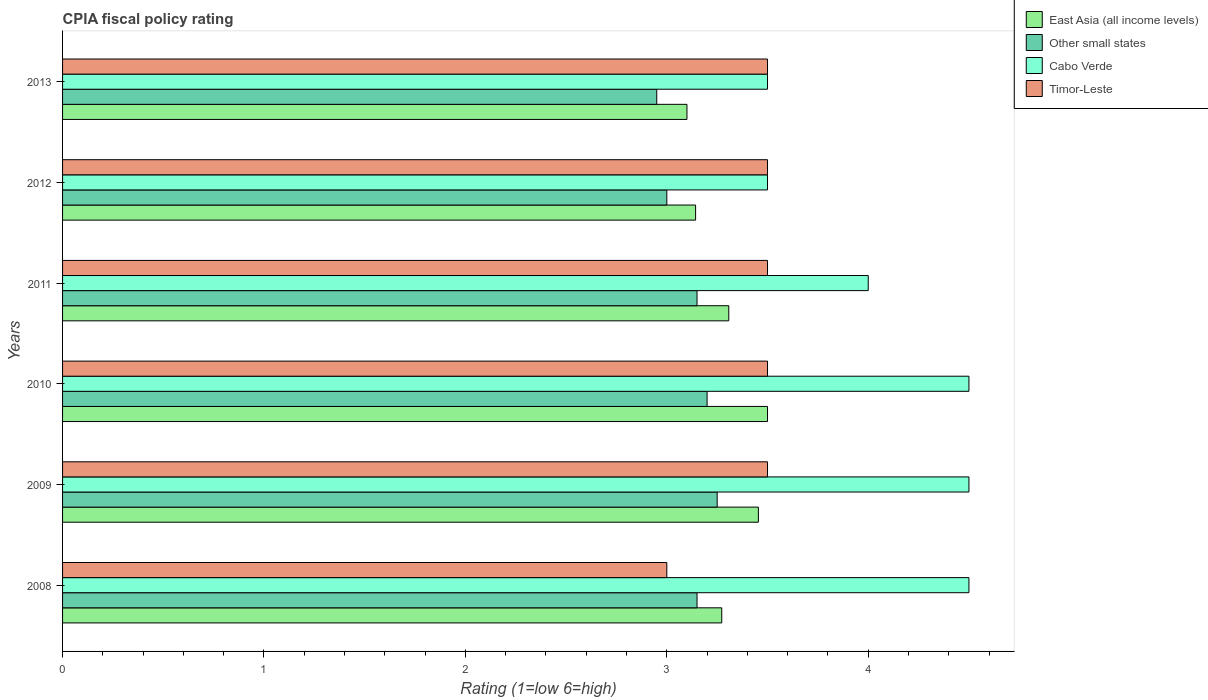How many different coloured bars are there?
Give a very brief answer. 4. Are the number of bars per tick equal to the number of legend labels?
Keep it short and to the point. Yes. How many bars are there on the 3rd tick from the bottom?
Ensure brevity in your answer.  4. What is the CPIA rating in East Asia (all income levels) in 2012?
Provide a succinct answer. 3.14. Across all years, what is the maximum CPIA rating in Other small states?
Offer a terse response. 3.25. Across all years, what is the minimum CPIA rating in Other small states?
Keep it short and to the point. 2.95. In which year was the CPIA rating in Cabo Verde minimum?
Ensure brevity in your answer.  2012. What is the total CPIA rating in Other small states in the graph?
Make the answer very short. 18.7. What is the difference between the CPIA rating in Other small states in 2009 and that in 2010?
Offer a very short reply. 0.05. What is the difference between the CPIA rating in East Asia (all income levels) in 2011 and the CPIA rating in Cabo Verde in 2013?
Make the answer very short. -0.19. What is the average CPIA rating in Other small states per year?
Your answer should be compact. 3.12. In the year 2013, what is the difference between the CPIA rating in Cabo Verde and CPIA rating in East Asia (all income levels)?
Provide a succinct answer. 0.4. Is the CPIA rating in Other small states in 2011 less than that in 2013?
Offer a very short reply. No. What is the difference between the highest and the second highest CPIA rating in East Asia (all income levels)?
Your answer should be compact. 0.05. What is the difference between the highest and the lowest CPIA rating in Other small states?
Offer a terse response. 0.3. In how many years, is the CPIA rating in Cabo Verde greater than the average CPIA rating in Cabo Verde taken over all years?
Provide a succinct answer. 3. What does the 3rd bar from the top in 2009 represents?
Your response must be concise. Other small states. What does the 3rd bar from the bottom in 2013 represents?
Provide a succinct answer. Cabo Verde. How many bars are there?
Provide a succinct answer. 24. Are all the bars in the graph horizontal?
Ensure brevity in your answer.  Yes. How many years are there in the graph?
Offer a very short reply. 6. Are the values on the major ticks of X-axis written in scientific E-notation?
Provide a succinct answer. No. Where does the legend appear in the graph?
Make the answer very short. Top right. How are the legend labels stacked?
Ensure brevity in your answer.  Vertical. What is the title of the graph?
Your answer should be compact. CPIA fiscal policy rating. Does "Peru" appear as one of the legend labels in the graph?
Provide a succinct answer. No. What is the label or title of the Y-axis?
Make the answer very short. Years. What is the Rating (1=low 6=high) in East Asia (all income levels) in 2008?
Offer a terse response. 3.27. What is the Rating (1=low 6=high) of Other small states in 2008?
Provide a short and direct response. 3.15. What is the Rating (1=low 6=high) of Timor-Leste in 2008?
Ensure brevity in your answer.  3. What is the Rating (1=low 6=high) in East Asia (all income levels) in 2009?
Offer a very short reply. 3.45. What is the Rating (1=low 6=high) in Other small states in 2009?
Your response must be concise. 3.25. What is the Rating (1=low 6=high) in Timor-Leste in 2010?
Provide a succinct answer. 3.5. What is the Rating (1=low 6=high) in East Asia (all income levels) in 2011?
Give a very brief answer. 3.31. What is the Rating (1=low 6=high) of Other small states in 2011?
Keep it short and to the point. 3.15. What is the Rating (1=low 6=high) in Cabo Verde in 2011?
Make the answer very short. 4. What is the Rating (1=low 6=high) in East Asia (all income levels) in 2012?
Your response must be concise. 3.14. What is the Rating (1=low 6=high) of Other small states in 2012?
Provide a succinct answer. 3. What is the Rating (1=low 6=high) in Cabo Verde in 2012?
Your answer should be compact. 3.5. What is the Rating (1=low 6=high) in Timor-Leste in 2012?
Provide a short and direct response. 3.5. What is the Rating (1=low 6=high) of Other small states in 2013?
Keep it short and to the point. 2.95. What is the Rating (1=low 6=high) in Cabo Verde in 2013?
Give a very brief answer. 3.5. What is the Rating (1=low 6=high) in Timor-Leste in 2013?
Your response must be concise. 3.5. Across all years, what is the maximum Rating (1=low 6=high) of East Asia (all income levels)?
Offer a very short reply. 3.5. Across all years, what is the minimum Rating (1=low 6=high) in Other small states?
Give a very brief answer. 2.95. Across all years, what is the minimum Rating (1=low 6=high) in Timor-Leste?
Your answer should be very brief. 3. What is the total Rating (1=low 6=high) of East Asia (all income levels) in the graph?
Your response must be concise. 19.78. What is the total Rating (1=low 6=high) in Timor-Leste in the graph?
Offer a terse response. 20.5. What is the difference between the Rating (1=low 6=high) in East Asia (all income levels) in 2008 and that in 2009?
Your response must be concise. -0.18. What is the difference between the Rating (1=low 6=high) of East Asia (all income levels) in 2008 and that in 2010?
Keep it short and to the point. -0.23. What is the difference between the Rating (1=low 6=high) in Timor-Leste in 2008 and that in 2010?
Provide a short and direct response. -0.5. What is the difference between the Rating (1=low 6=high) in East Asia (all income levels) in 2008 and that in 2011?
Your answer should be very brief. -0.04. What is the difference between the Rating (1=low 6=high) in Other small states in 2008 and that in 2011?
Make the answer very short. 0. What is the difference between the Rating (1=low 6=high) of Cabo Verde in 2008 and that in 2011?
Your response must be concise. 0.5. What is the difference between the Rating (1=low 6=high) of East Asia (all income levels) in 2008 and that in 2012?
Give a very brief answer. 0.13. What is the difference between the Rating (1=low 6=high) of Other small states in 2008 and that in 2012?
Keep it short and to the point. 0.15. What is the difference between the Rating (1=low 6=high) in Cabo Verde in 2008 and that in 2012?
Your answer should be very brief. 1. What is the difference between the Rating (1=low 6=high) in East Asia (all income levels) in 2008 and that in 2013?
Your response must be concise. 0.17. What is the difference between the Rating (1=low 6=high) of Other small states in 2008 and that in 2013?
Make the answer very short. 0.2. What is the difference between the Rating (1=low 6=high) in East Asia (all income levels) in 2009 and that in 2010?
Your answer should be very brief. -0.05. What is the difference between the Rating (1=low 6=high) in Other small states in 2009 and that in 2010?
Your answer should be compact. 0.05. What is the difference between the Rating (1=low 6=high) in Cabo Verde in 2009 and that in 2010?
Provide a short and direct response. 0. What is the difference between the Rating (1=low 6=high) in East Asia (all income levels) in 2009 and that in 2011?
Your answer should be very brief. 0.15. What is the difference between the Rating (1=low 6=high) of East Asia (all income levels) in 2009 and that in 2012?
Give a very brief answer. 0.31. What is the difference between the Rating (1=low 6=high) in Timor-Leste in 2009 and that in 2012?
Your response must be concise. 0. What is the difference between the Rating (1=low 6=high) in East Asia (all income levels) in 2009 and that in 2013?
Your response must be concise. 0.35. What is the difference between the Rating (1=low 6=high) of Other small states in 2009 and that in 2013?
Offer a terse response. 0.3. What is the difference between the Rating (1=low 6=high) of Cabo Verde in 2009 and that in 2013?
Your answer should be very brief. 1. What is the difference between the Rating (1=low 6=high) in Timor-Leste in 2009 and that in 2013?
Give a very brief answer. 0. What is the difference between the Rating (1=low 6=high) of East Asia (all income levels) in 2010 and that in 2011?
Your answer should be compact. 0.19. What is the difference between the Rating (1=low 6=high) of Other small states in 2010 and that in 2011?
Ensure brevity in your answer.  0.05. What is the difference between the Rating (1=low 6=high) of Timor-Leste in 2010 and that in 2011?
Make the answer very short. 0. What is the difference between the Rating (1=low 6=high) of East Asia (all income levels) in 2010 and that in 2012?
Give a very brief answer. 0.36. What is the difference between the Rating (1=low 6=high) of Cabo Verde in 2010 and that in 2012?
Your answer should be compact. 1. What is the difference between the Rating (1=low 6=high) of Timor-Leste in 2010 and that in 2012?
Provide a short and direct response. 0. What is the difference between the Rating (1=low 6=high) in East Asia (all income levels) in 2010 and that in 2013?
Your response must be concise. 0.4. What is the difference between the Rating (1=low 6=high) of Timor-Leste in 2010 and that in 2013?
Keep it short and to the point. 0. What is the difference between the Rating (1=low 6=high) in East Asia (all income levels) in 2011 and that in 2012?
Ensure brevity in your answer.  0.16. What is the difference between the Rating (1=low 6=high) in Other small states in 2011 and that in 2012?
Give a very brief answer. 0.15. What is the difference between the Rating (1=low 6=high) of Timor-Leste in 2011 and that in 2012?
Give a very brief answer. 0. What is the difference between the Rating (1=low 6=high) of East Asia (all income levels) in 2011 and that in 2013?
Give a very brief answer. 0.21. What is the difference between the Rating (1=low 6=high) of Other small states in 2011 and that in 2013?
Give a very brief answer. 0.2. What is the difference between the Rating (1=low 6=high) of Cabo Verde in 2011 and that in 2013?
Provide a short and direct response. 0.5. What is the difference between the Rating (1=low 6=high) in Timor-Leste in 2011 and that in 2013?
Offer a terse response. 0. What is the difference between the Rating (1=low 6=high) in East Asia (all income levels) in 2012 and that in 2013?
Your response must be concise. 0.04. What is the difference between the Rating (1=low 6=high) of Cabo Verde in 2012 and that in 2013?
Provide a succinct answer. 0. What is the difference between the Rating (1=low 6=high) in East Asia (all income levels) in 2008 and the Rating (1=low 6=high) in Other small states in 2009?
Provide a short and direct response. 0.02. What is the difference between the Rating (1=low 6=high) in East Asia (all income levels) in 2008 and the Rating (1=low 6=high) in Cabo Verde in 2009?
Offer a very short reply. -1.23. What is the difference between the Rating (1=low 6=high) in East Asia (all income levels) in 2008 and the Rating (1=low 6=high) in Timor-Leste in 2009?
Provide a succinct answer. -0.23. What is the difference between the Rating (1=low 6=high) of Other small states in 2008 and the Rating (1=low 6=high) of Cabo Verde in 2009?
Give a very brief answer. -1.35. What is the difference between the Rating (1=low 6=high) in Other small states in 2008 and the Rating (1=low 6=high) in Timor-Leste in 2009?
Provide a short and direct response. -0.35. What is the difference between the Rating (1=low 6=high) of East Asia (all income levels) in 2008 and the Rating (1=low 6=high) of Other small states in 2010?
Provide a succinct answer. 0.07. What is the difference between the Rating (1=low 6=high) of East Asia (all income levels) in 2008 and the Rating (1=low 6=high) of Cabo Verde in 2010?
Provide a short and direct response. -1.23. What is the difference between the Rating (1=low 6=high) in East Asia (all income levels) in 2008 and the Rating (1=low 6=high) in Timor-Leste in 2010?
Make the answer very short. -0.23. What is the difference between the Rating (1=low 6=high) in Other small states in 2008 and the Rating (1=low 6=high) in Cabo Verde in 2010?
Your answer should be compact. -1.35. What is the difference between the Rating (1=low 6=high) of Other small states in 2008 and the Rating (1=low 6=high) of Timor-Leste in 2010?
Ensure brevity in your answer.  -0.35. What is the difference between the Rating (1=low 6=high) of East Asia (all income levels) in 2008 and the Rating (1=low 6=high) of Other small states in 2011?
Your answer should be compact. 0.12. What is the difference between the Rating (1=low 6=high) in East Asia (all income levels) in 2008 and the Rating (1=low 6=high) in Cabo Verde in 2011?
Give a very brief answer. -0.73. What is the difference between the Rating (1=low 6=high) in East Asia (all income levels) in 2008 and the Rating (1=low 6=high) in Timor-Leste in 2011?
Provide a short and direct response. -0.23. What is the difference between the Rating (1=low 6=high) of Other small states in 2008 and the Rating (1=low 6=high) of Cabo Verde in 2011?
Provide a short and direct response. -0.85. What is the difference between the Rating (1=low 6=high) in Other small states in 2008 and the Rating (1=low 6=high) in Timor-Leste in 2011?
Offer a very short reply. -0.35. What is the difference between the Rating (1=low 6=high) of East Asia (all income levels) in 2008 and the Rating (1=low 6=high) of Other small states in 2012?
Your answer should be very brief. 0.27. What is the difference between the Rating (1=low 6=high) in East Asia (all income levels) in 2008 and the Rating (1=low 6=high) in Cabo Verde in 2012?
Make the answer very short. -0.23. What is the difference between the Rating (1=low 6=high) of East Asia (all income levels) in 2008 and the Rating (1=low 6=high) of Timor-Leste in 2012?
Provide a succinct answer. -0.23. What is the difference between the Rating (1=low 6=high) of Other small states in 2008 and the Rating (1=low 6=high) of Cabo Verde in 2012?
Ensure brevity in your answer.  -0.35. What is the difference between the Rating (1=low 6=high) of Other small states in 2008 and the Rating (1=low 6=high) of Timor-Leste in 2012?
Give a very brief answer. -0.35. What is the difference between the Rating (1=low 6=high) in Cabo Verde in 2008 and the Rating (1=low 6=high) in Timor-Leste in 2012?
Your answer should be compact. 1. What is the difference between the Rating (1=low 6=high) in East Asia (all income levels) in 2008 and the Rating (1=low 6=high) in Other small states in 2013?
Your answer should be very brief. 0.32. What is the difference between the Rating (1=low 6=high) in East Asia (all income levels) in 2008 and the Rating (1=low 6=high) in Cabo Verde in 2013?
Keep it short and to the point. -0.23. What is the difference between the Rating (1=low 6=high) of East Asia (all income levels) in 2008 and the Rating (1=low 6=high) of Timor-Leste in 2013?
Your answer should be very brief. -0.23. What is the difference between the Rating (1=low 6=high) in Other small states in 2008 and the Rating (1=low 6=high) in Cabo Verde in 2013?
Provide a succinct answer. -0.35. What is the difference between the Rating (1=low 6=high) of Other small states in 2008 and the Rating (1=low 6=high) of Timor-Leste in 2013?
Your answer should be compact. -0.35. What is the difference between the Rating (1=low 6=high) in East Asia (all income levels) in 2009 and the Rating (1=low 6=high) in Other small states in 2010?
Your response must be concise. 0.25. What is the difference between the Rating (1=low 6=high) in East Asia (all income levels) in 2009 and the Rating (1=low 6=high) in Cabo Verde in 2010?
Ensure brevity in your answer.  -1.05. What is the difference between the Rating (1=low 6=high) in East Asia (all income levels) in 2009 and the Rating (1=low 6=high) in Timor-Leste in 2010?
Make the answer very short. -0.05. What is the difference between the Rating (1=low 6=high) of Other small states in 2009 and the Rating (1=low 6=high) of Cabo Verde in 2010?
Keep it short and to the point. -1.25. What is the difference between the Rating (1=low 6=high) in Other small states in 2009 and the Rating (1=low 6=high) in Timor-Leste in 2010?
Provide a short and direct response. -0.25. What is the difference between the Rating (1=low 6=high) of Cabo Verde in 2009 and the Rating (1=low 6=high) of Timor-Leste in 2010?
Ensure brevity in your answer.  1. What is the difference between the Rating (1=low 6=high) in East Asia (all income levels) in 2009 and the Rating (1=low 6=high) in Other small states in 2011?
Your answer should be compact. 0.3. What is the difference between the Rating (1=low 6=high) of East Asia (all income levels) in 2009 and the Rating (1=low 6=high) of Cabo Verde in 2011?
Your answer should be compact. -0.55. What is the difference between the Rating (1=low 6=high) of East Asia (all income levels) in 2009 and the Rating (1=low 6=high) of Timor-Leste in 2011?
Make the answer very short. -0.05. What is the difference between the Rating (1=low 6=high) of Other small states in 2009 and the Rating (1=low 6=high) of Cabo Verde in 2011?
Provide a succinct answer. -0.75. What is the difference between the Rating (1=low 6=high) of Other small states in 2009 and the Rating (1=low 6=high) of Timor-Leste in 2011?
Make the answer very short. -0.25. What is the difference between the Rating (1=low 6=high) in East Asia (all income levels) in 2009 and the Rating (1=low 6=high) in Other small states in 2012?
Provide a succinct answer. 0.45. What is the difference between the Rating (1=low 6=high) in East Asia (all income levels) in 2009 and the Rating (1=low 6=high) in Cabo Verde in 2012?
Give a very brief answer. -0.05. What is the difference between the Rating (1=low 6=high) in East Asia (all income levels) in 2009 and the Rating (1=low 6=high) in Timor-Leste in 2012?
Provide a succinct answer. -0.05. What is the difference between the Rating (1=low 6=high) of Other small states in 2009 and the Rating (1=low 6=high) of Cabo Verde in 2012?
Provide a succinct answer. -0.25. What is the difference between the Rating (1=low 6=high) of Other small states in 2009 and the Rating (1=low 6=high) of Timor-Leste in 2012?
Make the answer very short. -0.25. What is the difference between the Rating (1=low 6=high) in East Asia (all income levels) in 2009 and the Rating (1=low 6=high) in Other small states in 2013?
Keep it short and to the point. 0.5. What is the difference between the Rating (1=low 6=high) of East Asia (all income levels) in 2009 and the Rating (1=low 6=high) of Cabo Verde in 2013?
Provide a short and direct response. -0.05. What is the difference between the Rating (1=low 6=high) in East Asia (all income levels) in 2009 and the Rating (1=low 6=high) in Timor-Leste in 2013?
Offer a very short reply. -0.05. What is the difference between the Rating (1=low 6=high) in Other small states in 2009 and the Rating (1=low 6=high) in Cabo Verde in 2013?
Offer a terse response. -0.25. What is the difference between the Rating (1=low 6=high) of Cabo Verde in 2009 and the Rating (1=low 6=high) of Timor-Leste in 2013?
Your response must be concise. 1. What is the difference between the Rating (1=low 6=high) of East Asia (all income levels) in 2010 and the Rating (1=low 6=high) of Cabo Verde in 2011?
Give a very brief answer. -0.5. What is the difference between the Rating (1=low 6=high) of Other small states in 2010 and the Rating (1=low 6=high) of Timor-Leste in 2011?
Give a very brief answer. -0.3. What is the difference between the Rating (1=low 6=high) of Cabo Verde in 2010 and the Rating (1=low 6=high) of Timor-Leste in 2011?
Provide a succinct answer. 1. What is the difference between the Rating (1=low 6=high) of East Asia (all income levels) in 2010 and the Rating (1=low 6=high) of Cabo Verde in 2012?
Provide a short and direct response. 0. What is the difference between the Rating (1=low 6=high) in East Asia (all income levels) in 2010 and the Rating (1=low 6=high) in Other small states in 2013?
Provide a succinct answer. 0.55. What is the difference between the Rating (1=low 6=high) of East Asia (all income levels) in 2010 and the Rating (1=low 6=high) of Timor-Leste in 2013?
Make the answer very short. 0. What is the difference between the Rating (1=low 6=high) in Other small states in 2010 and the Rating (1=low 6=high) in Cabo Verde in 2013?
Provide a succinct answer. -0.3. What is the difference between the Rating (1=low 6=high) of Cabo Verde in 2010 and the Rating (1=low 6=high) of Timor-Leste in 2013?
Ensure brevity in your answer.  1. What is the difference between the Rating (1=low 6=high) of East Asia (all income levels) in 2011 and the Rating (1=low 6=high) of Other small states in 2012?
Your answer should be compact. 0.31. What is the difference between the Rating (1=low 6=high) of East Asia (all income levels) in 2011 and the Rating (1=low 6=high) of Cabo Verde in 2012?
Keep it short and to the point. -0.19. What is the difference between the Rating (1=low 6=high) of East Asia (all income levels) in 2011 and the Rating (1=low 6=high) of Timor-Leste in 2012?
Keep it short and to the point. -0.19. What is the difference between the Rating (1=low 6=high) in Other small states in 2011 and the Rating (1=low 6=high) in Cabo Verde in 2012?
Your answer should be compact. -0.35. What is the difference between the Rating (1=low 6=high) in Other small states in 2011 and the Rating (1=low 6=high) in Timor-Leste in 2012?
Offer a terse response. -0.35. What is the difference between the Rating (1=low 6=high) in East Asia (all income levels) in 2011 and the Rating (1=low 6=high) in Other small states in 2013?
Offer a very short reply. 0.36. What is the difference between the Rating (1=low 6=high) of East Asia (all income levels) in 2011 and the Rating (1=low 6=high) of Cabo Verde in 2013?
Your response must be concise. -0.19. What is the difference between the Rating (1=low 6=high) in East Asia (all income levels) in 2011 and the Rating (1=low 6=high) in Timor-Leste in 2013?
Ensure brevity in your answer.  -0.19. What is the difference between the Rating (1=low 6=high) in Other small states in 2011 and the Rating (1=low 6=high) in Cabo Verde in 2013?
Keep it short and to the point. -0.35. What is the difference between the Rating (1=low 6=high) of Other small states in 2011 and the Rating (1=low 6=high) of Timor-Leste in 2013?
Your response must be concise. -0.35. What is the difference between the Rating (1=low 6=high) of Cabo Verde in 2011 and the Rating (1=low 6=high) of Timor-Leste in 2013?
Provide a short and direct response. 0.5. What is the difference between the Rating (1=low 6=high) of East Asia (all income levels) in 2012 and the Rating (1=low 6=high) of Other small states in 2013?
Provide a succinct answer. 0.19. What is the difference between the Rating (1=low 6=high) of East Asia (all income levels) in 2012 and the Rating (1=low 6=high) of Cabo Verde in 2013?
Your answer should be very brief. -0.36. What is the difference between the Rating (1=low 6=high) in East Asia (all income levels) in 2012 and the Rating (1=low 6=high) in Timor-Leste in 2013?
Make the answer very short. -0.36. What is the average Rating (1=low 6=high) in East Asia (all income levels) per year?
Make the answer very short. 3.3. What is the average Rating (1=low 6=high) in Other small states per year?
Provide a short and direct response. 3.12. What is the average Rating (1=low 6=high) in Cabo Verde per year?
Offer a very short reply. 4.08. What is the average Rating (1=low 6=high) of Timor-Leste per year?
Your response must be concise. 3.42. In the year 2008, what is the difference between the Rating (1=low 6=high) of East Asia (all income levels) and Rating (1=low 6=high) of Other small states?
Keep it short and to the point. 0.12. In the year 2008, what is the difference between the Rating (1=low 6=high) of East Asia (all income levels) and Rating (1=low 6=high) of Cabo Verde?
Your response must be concise. -1.23. In the year 2008, what is the difference between the Rating (1=low 6=high) of East Asia (all income levels) and Rating (1=low 6=high) of Timor-Leste?
Provide a short and direct response. 0.27. In the year 2008, what is the difference between the Rating (1=low 6=high) in Other small states and Rating (1=low 6=high) in Cabo Verde?
Provide a short and direct response. -1.35. In the year 2008, what is the difference between the Rating (1=low 6=high) in Other small states and Rating (1=low 6=high) in Timor-Leste?
Ensure brevity in your answer.  0.15. In the year 2008, what is the difference between the Rating (1=low 6=high) in Cabo Verde and Rating (1=low 6=high) in Timor-Leste?
Your response must be concise. 1.5. In the year 2009, what is the difference between the Rating (1=low 6=high) of East Asia (all income levels) and Rating (1=low 6=high) of Other small states?
Offer a terse response. 0.2. In the year 2009, what is the difference between the Rating (1=low 6=high) in East Asia (all income levels) and Rating (1=low 6=high) in Cabo Verde?
Your answer should be compact. -1.05. In the year 2009, what is the difference between the Rating (1=low 6=high) of East Asia (all income levels) and Rating (1=low 6=high) of Timor-Leste?
Provide a succinct answer. -0.05. In the year 2009, what is the difference between the Rating (1=low 6=high) of Other small states and Rating (1=low 6=high) of Cabo Verde?
Your answer should be compact. -1.25. In the year 2009, what is the difference between the Rating (1=low 6=high) of Other small states and Rating (1=low 6=high) of Timor-Leste?
Your answer should be compact. -0.25. In the year 2009, what is the difference between the Rating (1=low 6=high) in Cabo Verde and Rating (1=low 6=high) in Timor-Leste?
Your response must be concise. 1. In the year 2010, what is the difference between the Rating (1=low 6=high) in East Asia (all income levels) and Rating (1=low 6=high) in Other small states?
Provide a short and direct response. 0.3. In the year 2010, what is the difference between the Rating (1=low 6=high) of East Asia (all income levels) and Rating (1=low 6=high) of Timor-Leste?
Your response must be concise. 0. In the year 2010, what is the difference between the Rating (1=low 6=high) of Other small states and Rating (1=low 6=high) of Cabo Verde?
Ensure brevity in your answer.  -1.3. In the year 2010, what is the difference between the Rating (1=low 6=high) in Other small states and Rating (1=low 6=high) in Timor-Leste?
Offer a very short reply. -0.3. In the year 2010, what is the difference between the Rating (1=low 6=high) in Cabo Verde and Rating (1=low 6=high) in Timor-Leste?
Provide a short and direct response. 1. In the year 2011, what is the difference between the Rating (1=low 6=high) in East Asia (all income levels) and Rating (1=low 6=high) in Other small states?
Offer a very short reply. 0.16. In the year 2011, what is the difference between the Rating (1=low 6=high) in East Asia (all income levels) and Rating (1=low 6=high) in Cabo Verde?
Offer a very short reply. -0.69. In the year 2011, what is the difference between the Rating (1=low 6=high) in East Asia (all income levels) and Rating (1=low 6=high) in Timor-Leste?
Your answer should be compact. -0.19. In the year 2011, what is the difference between the Rating (1=low 6=high) of Other small states and Rating (1=low 6=high) of Cabo Verde?
Keep it short and to the point. -0.85. In the year 2011, what is the difference between the Rating (1=low 6=high) of Other small states and Rating (1=low 6=high) of Timor-Leste?
Offer a very short reply. -0.35. In the year 2011, what is the difference between the Rating (1=low 6=high) in Cabo Verde and Rating (1=low 6=high) in Timor-Leste?
Ensure brevity in your answer.  0.5. In the year 2012, what is the difference between the Rating (1=low 6=high) of East Asia (all income levels) and Rating (1=low 6=high) of Other small states?
Your response must be concise. 0.14. In the year 2012, what is the difference between the Rating (1=low 6=high) in East Asia (all income levels) and Rating (1=low 6=high) in Cabo Verde?
Your answer should be compact. -0.36. In the year 2012, what is the difference between the Rating (1=low 6=high) in East Asia (all income levels) and Rating (1=low 6=high) in Timor-Leste?
Your answer should be very brief. -0.36. In the year 2012, what is the difference between the Rating (1=low 6=high) in Other small states and Rating (1=low 6=high) in Timor-Leste?
Your answer should be compact. -0.5. In the year 2013, what is the difference between the Rating (1=low 6=high) of East Asia (all income levels) and Rating (1=low 6=high) of Cabo Verde?
Give a very brief answer. -0.4. In the year 2013, what is the difference between the Rating (1=low 6=high) in Other small states and Rating (1=low 6=high) in Cabo Verde?
Give a very brief answer. -0.55. In the year 2013, what is the difference between the Rating (1=low 6=high) of Other small states and Rating (1=low 6=high) of Timor-Leste?
Give a very brief answer. -0.55. What is the ratio of the Rating (1=low 6=high) in Other small states in 2008 to that in 2009?
Ensure brevity in your answer.  0.97. What is the ratio of the Rating (1=low 6=high) of Cabo Verde in 2008 to that in 2009?
Make the answer very short. 1. What is the ratio of the Rating (1=low 6=high) of Timor-Leste in 2008 to that in 2009?
Make the answer very short. 0.86. What is the ratio of the Rating (1=low 6=high) of East Asia (all income levels) in 2008 to that in 2010?
Ensure brevity in your answer.  0.94. What is the ratio of the Rating (1=low 6=high) of Other small states in 2008 to that in 2010?
Provide a succinct answer. 0.98. What is the ratio of the Rating (1=low 6=high) in Timor-Leste in 2008 to that in 2010?
Give a very brief answer. 0.86. What is the ratio of the Rating (1=low 6=high) of East Asia (all income levels) in 2008 to that in 2011?
Make the answer very short. 0.99. What is the ratio of the Rating (1=low 6=high) in Other small states in 2008 to that in 2011?
Your answer should be compact. 1. What is the ratio of the Rating (1=low 6=high) in Cabo Verde in 2008 to that in 2011?
Offer a very short reply. 1.12. What is the ratio of the Rating (1=low 6=high) in Timor-Leste in 2008 to that in 2011?
Make the answer very short. 0.86. What is the ratio of the Rating (1=low 6=high) in East Asia (all income levels) in 2008 to that in 2012?
Offer a very short reply. 1.04. What is the ratio of the Rating (1=low 6=high) of Cabo Verde in 2008 to that in 2012?
Give a very brief answer. 1.29. What is the ratio of the Rating (1=low 6=high) of Timor-Leste in 2008 to that in 2012?
Your answer should be very brief. 0.86. What is the ratio of the Rating (1=low 6=high) in East Asia (all income levels) in 2008 to that in 2013?
Your response must be concise. 1.06. What is the ratio of the Rating (1=low 6=high) of Other small states in 2008 to that in 2013?
Your response must be concise. 1.07. What is the ratio of the Rating (1=low 6=high) of Cabo Verde in 2008 to that in 2013?
Give a very brief answer. 1.29. What is the ratio of the Rating (1=low 6=high) of Timor-Leste in 2008 to that in 2013?
Your answer should be very brief. 0.86. What is the ratio of the Rating (1=low 6=high) in Other small states in 2009 to that in 2010?
Give a very brief answer. 1.02. What is the ratio of the Rating (1=low 6=high) in Timor-Leste in 2009 to that in 2010?
Give a very brief answer. 1. What is the ratio of the Rating (1=low 6=high) in East Asia (all income levels) in 2009 to that in 2011?
Keep it short and to the point. 1.04. What is the ratio of the Rating (1=low 6=high) of Other small states in 2009 to that in 2011?
Your answer should be very brief. 1.03. What is the ratio of the Rating (1=low 6=high) of East Asia (all income levels) in 2009 to that in 2012?
Keep it short and to the point. 1.1. What is the ratio of the Rating (1=low 6=high) of Timor-Leste in 2009 to that in 2012?
Your response must be concise. 1. What is the ratio of the Rating (1=low 6=high) in East Asia (all income levels) in 2009 to that in 2013?
Offer a very short reply. 1.11. What is the ratio of the Rating (1=low 6=high) of Other small states in 2009 to that in 2013?
Provide a short and direct response. 1.1. What is the ratio of the Rating (1=low 6=high) of Cabo Verde in 2009 to that in 2013?
Provide a short and direct response. 1.29. What is the ratio of the Rating (1=low 6=high) in Timor-Leste in 2009 to that in 2013?
Ensure brevity in your answer.  1. What is the ratio of the Rating (1=low 6=high) in East Asia (all income levels) in 2010 to that in 2011?
Your answer should be compact. 1.06. What is the ratio of the Rating (1=low 6=high) of Other small states in 2010 to that in 2011?
Keep it short and to the point. 1.02. What is the ratio of the Rating (1=low 6=high) in Cabo Verde in 2010 to that in 2011?
Make the answer very short. 1.12. What is the ratio of the Rating (1=low 6=high) in Timor-Leste in 2010 to that in 2011?
Provide a succinct answer. 1. What is the ratio of the Rating (1=low 6=high) of East Asia (all income levels) in 2010 to that in 2012?
Your answer should be compact. 1.11. What is the ratio of the Rating (1=low 6=high) in Other small states in 2010 to that in 2012?
Your answer should be very brief. 1.07. What is the ratio of the Rating (1=low 6=high) in East Asia (all income levels) in 2010 to that in 2013?
Ensure brevity in your answer.  1.13. What is the ratio of the Rating (1=low 6=high) in Other small states in 2010 to that in 2013?
Your answer should be very brief. 1.08. What is the ratio of the Rating (1=low 6=high) of Timor-Leste in 2010 to that in 2013?
Your answer should be compact. 1. What is the ratio of the Rating (1=low 6=high) in East Asia (all income levels) in 2011 to that in 2012?
Provide a succinct answer. 1.05. What is the ratio of the Rating (1=low 6=high) of Cabo Verde in 2011 to that in 2012?
Make the answer very short. 1.14. What is the ratio of the Rating (1=low 6=high) of East Asia (all income levels) in 2011 to that in 2013?
Give a very brief answer. 1.07. What is the ratio of the Rating (1=low 6=high) of Other small states in 2011 to that in 2013?
Your answer should be compact. 1.07. What is the ratio of the Rating (1=low 6=high) in East Asia (all income levels) in 2012 to that in 2013?
Offer a very short reply. 1.01. What is the ratio of the Rating (1=low 6=high) in Other small states in 2012 to that in 2013?
Offer a terse response. 1.02. What is the ratio of the Rating (1=low 6=high) of Timor-Leste in 2012 to that in 2013?
Give a very brief answer. 1. What is the difference between the highest and the second highest Rating (1=low 6=high) of East Asia (all income levels)?
Offer a very short reply. 0.05. What is the difference between the highest and the second highest Rating (1=low 6=high) of Other small states?
Your response must be concise. 0.05. What is the difference between the highest and the second highest Rating (1=low 6=high) in Cabo Verde?
Offer a terse response. 0. What is the difference between the highest and the lowest Rating (1=low 6=high) of Cabo Verde?
Your answer should be compact. 1. 